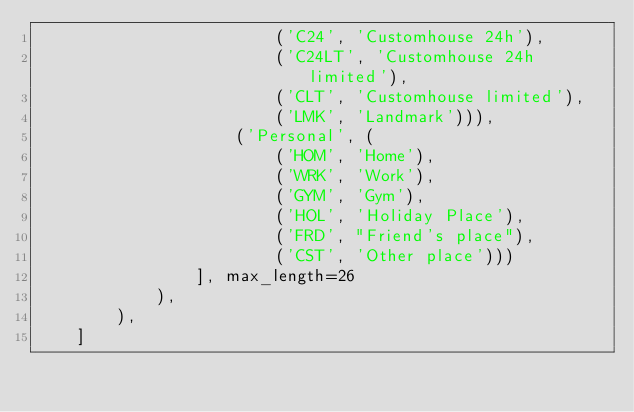<code> <loc_0><loc_0><loc_500><loc_500><_Python_>                        ('C24', 'Customhouse 24h'),
                        ('C24LT', 'Customhouse 24h limited'),
                        ('CLT', 'Customhouse limited'),
                        ('LMK', 'Landmark'))),
                    ('Personal', (
                        ('HOM', 'Home'),
                        ('WRK', 'Work'),
                        ('GYM', 'Gym'),
                        ('HOL', 'Holiday Place'),
                        ('FRD', "Friend's place"),
                        ('CST', 'Other place')))
                ], max_length=26
            ),
        ),
    ]
</code> 